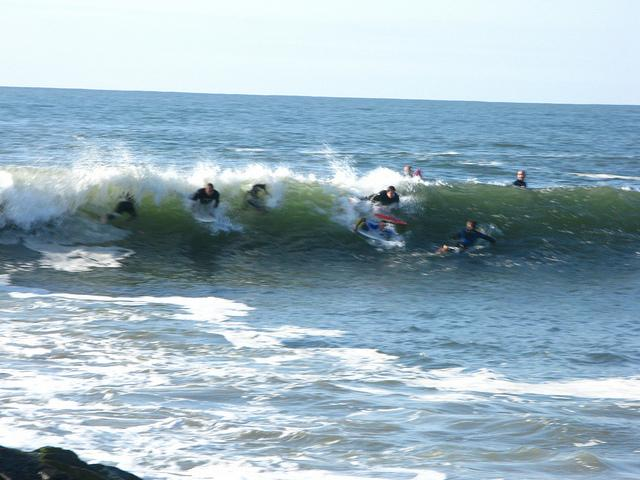What are the surfers in a push up position attempting to do? stand 